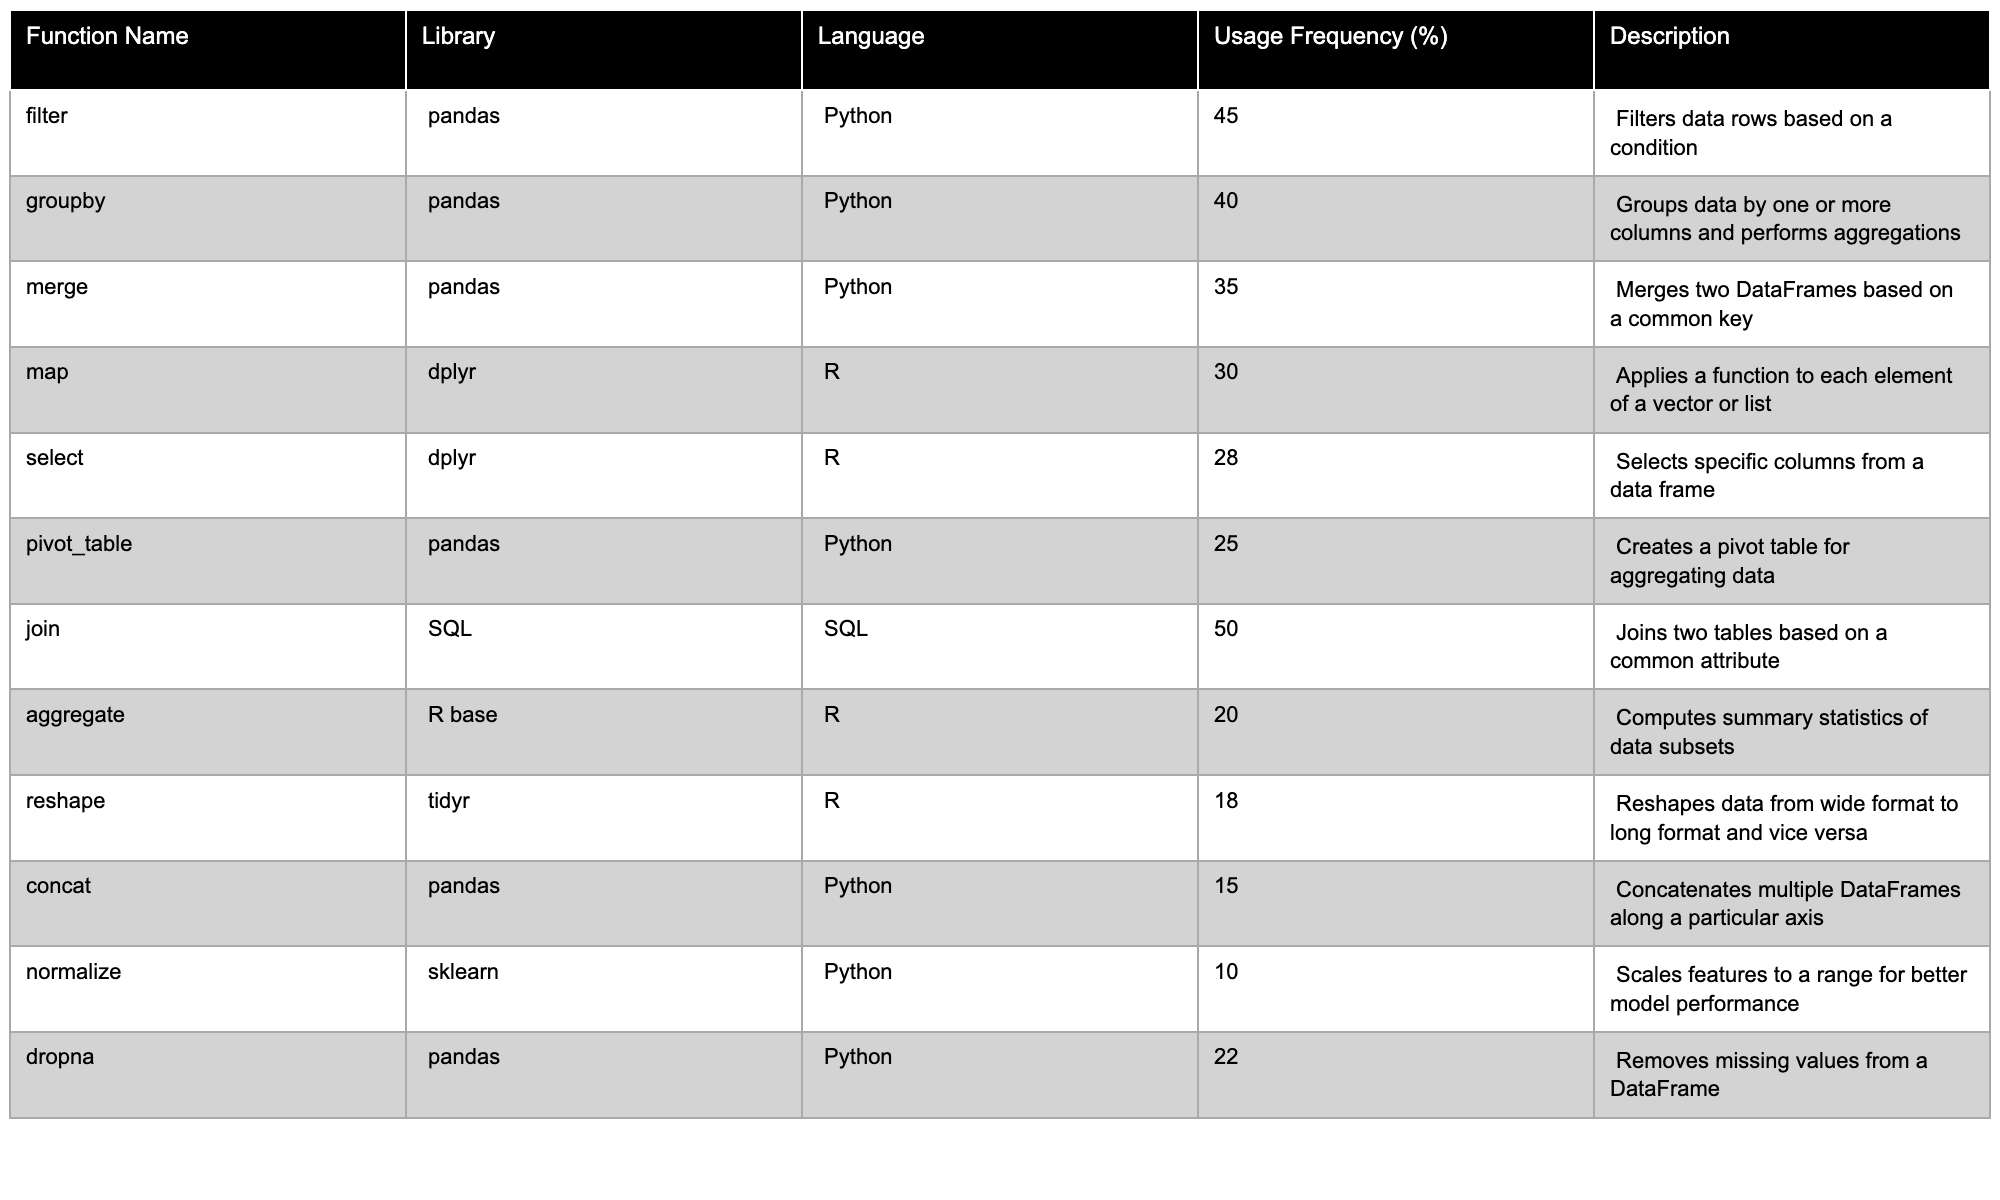What is the usage frequency of the 'filter' function? The table shows that the usage frequency of the 'filter' function under the pandas library in Python is 45%.
Answer: 45% Which function has the highest usage frequency in the SQL language? Looking at the SQL section, the 'join' function has the highest usage frequency of 50%.
Answer: 50% How many functions have a usage frequency of 20% or below? In the table, the functions 'aggregate' (20%), 'reshape' (18%), and 'normalize' (10%) have frequencies of 20% or below, totaling 3 functions.
Answer: 3 What is the most common data manipulation function across all languages? Comparing all usage frequencies, 'join' (50%) ranks as the most common overall, and 'filter' (45%) follows.
Answer: join Is the usage frequency of the 'dropna' function higher than that of 'normalize'? The table indicates 'dropna' has a usage frequency of 22%, while 'normalize' has 10%, making 'dropna' more frequent.
Answer: Yes What is the average usage frequency of functions in the R language? The R functions have the following usage frequencies: 'map' (30%), 'select' (28%), 'aggregate' (20%), and 'reshape' (18%). The average can be calculated as (30 + 28 + 20 + 18) / 4 = 24.
Answer: 24 Are there more data manipulation functions in Python compared to R or SQL? The table lists 6 functions for Python (filter, groupby, merge, pivot_table, concat, dropna), 4 for R (map, select, aggregate, reshape), and 1 for SQL (join). Therefore, Python has more functions.
Answer: Yes What is the difference in usage frequency between the 'merge' function and the 'aggregate' function? The 'merge' function has a frequency of 35%, while 'aggregate' has 20%. The difference is 35 - 20 = 15%.
Answer: 15% Which library has the highest reported usage frequency for data manipulation functions? The table shows the highest single usage frequency for 'join' in SQL (50%), but summing all Python functions' frequencies gives 45 + 40 + 35 + 25 + 15 + 22 = 182%. This suggests that overall, Python is the most used for data manipulation.
Answer: Python Which two functions are closest in usage frequency, and what are their frequencies? 'concat' (15%) and 'normalize' (10%) have the closest frequencies, with a difference of 5%.
Answer: concat and normalize (15% and 10%) 